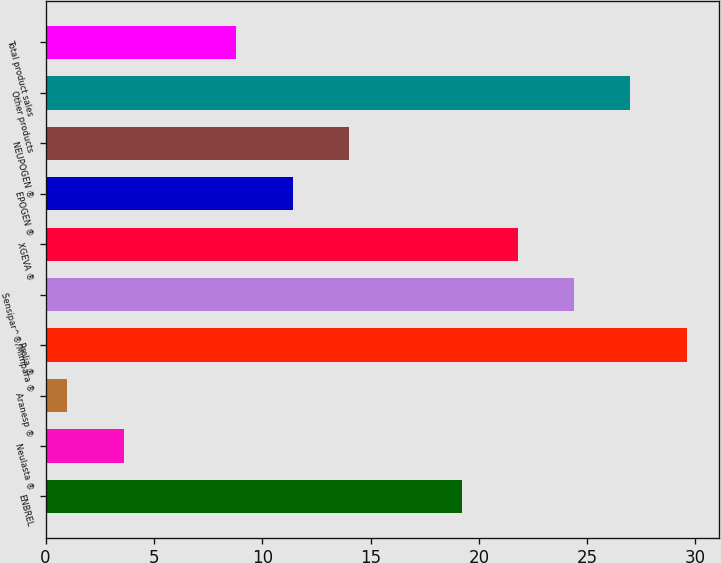Convert chart. <chart><loc_0><loc_0><loc_500><loc_500><bar_chart><fcel>ENBREL<fcel>Neulasta ®<fcel>Aranesp ®<fcel>Prolia ®<fcel>Sensipar^®/Mimpara ®<fcel>XGEVA ®<fcel>EPOGEN ®<fcel>NEUPOGEN ®<fcel>Other products<fcel>Total product sales<nl><fcel>19.2<fcel>3.6<fcel>1<fcel>29.6<fcel>24.4<fcel>21.8<fcel>11.4<fcel>14<fcel>27<fcel>8.8<nl></chart> 